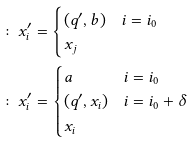<formula> <loc_0><loc_0><loc_500><loc_500>\colon & x ^ { \prime } _ { i } = \begin{cases} ( q ^ { \prime } , b ) & i = i _ { 0 } \\ x _ { j } & \end{cases} \\ \colon & x ^ { \prime } _ { i } = \begin{cases} a & i = i _ { 0 } \\ ( q ^ { \prime } , x _ { i } ) & i = i _ { 0 } + \delta \\ x _ { i } & \end{cases}</formula> 